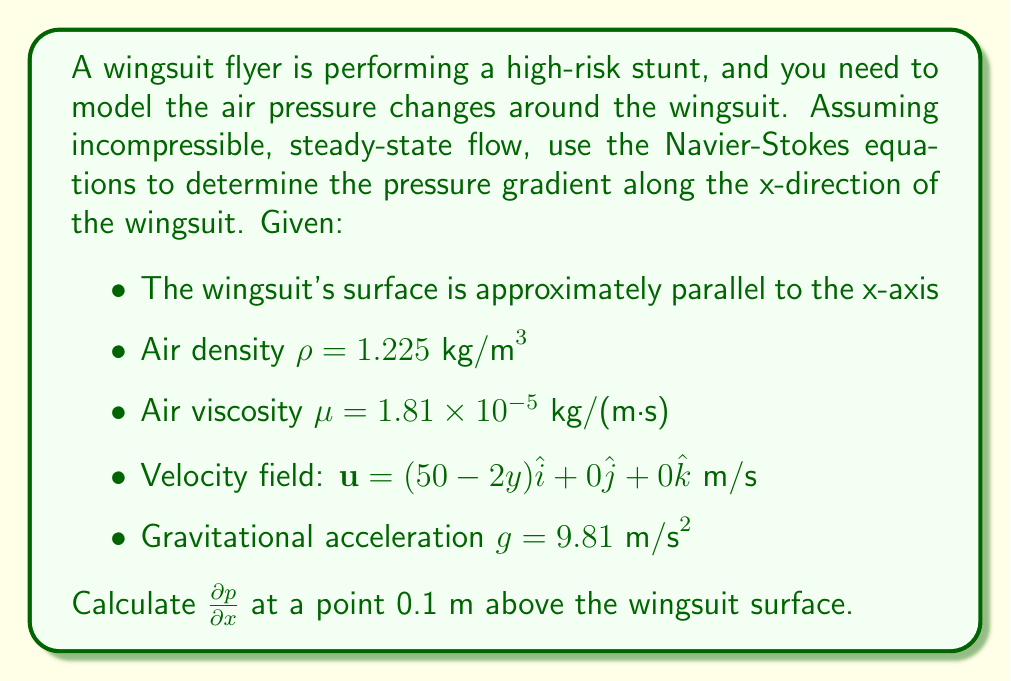Could you help me with this problem? To solve this problem, we'll use the x-component of the Navier-Stokes equations for incompressible, steady-state flow:

$$\rho\left(u\frac{\partial u}{\partial x} + v\frac{\partial u}{\partial y} + w\frac{\partial u}{\partial z}\right) = -\frac{\partial p}{\partial x} + \mu\left(\frac{\partial^2 u}{\partial x^2} + \frac{\partial^2 u}{\partial y^2} + \frac{\partial^2 u}{\partial z^2}\right) + \rho g_x$$

Given the velocity field $\mathbf{u} = (50 - 2y)\hat{i} + 0\hat{j} + 0\hat{k}$, we can identify:

$u = 50 - 2y$
$v = 0$
$w = 0$

Step 1: Calculate the partial derivatives:
$\frac{\partial u}{\partial x} = 0$
$\frac{\partial u}{\partial y} = -2$
$\frac{\partial u}{\partial z} = 0$

$\frac{\partial^2 u}{\partial x^2} = 0$
$\frac{\partial^2 u}{\partial y^2} = 0$
$\frac{\partial^2 u}{\partial z^2} = 0$

Step 2: Substitute into the Navier-Stokes equation:

$$\rho\left((50-2y)\cdot 0 + 0\cdot(-2) + 0\cdot 0\right) = -\frac{\partial p}{\partial x} + \mu(0 + 0 + 0) + \rho g_x$$

Step 3: Simplify:

$$0 = -\frac{\partial p}{\partial x} + \rho g_x$$

Step 4: Solve for $\frac{\partial p}{\partial x}$:

$$\frac{\partial p}{\partial x} = \rho g_x$$

Since the wingsuit surface is approximately parallel to the x-axis, we can assume $g_x = 0$.

Step 5: Substitute the given values:

$$\frac{\partial p}{\partial x} = (1.225 \text{ kg/m}^3)(0 \text{ m/s}^2) = 0 \text{ Pa/m}$$

Therefore, the pressure gradient along the x-direction is zero, indicating constant pressure along the wingsuit in the x-direction.
Answer: $\frac{\partial p}{\partial x} = 0 \text{ Pa/m}$ 